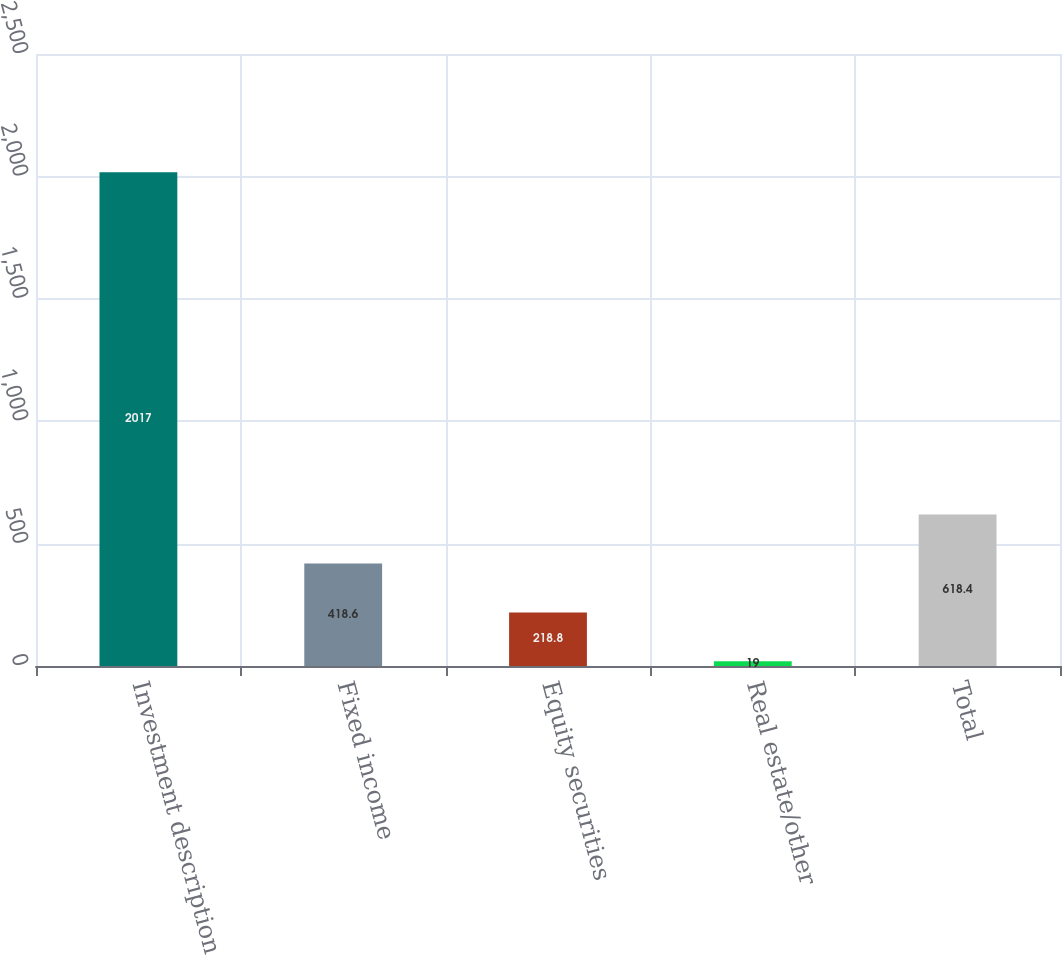Convert chart to OTSL. <chart><loc_0><loc_0><loc_500><loc_500><bar_chart><fcel>Investment description<fcel>Fixed income<fcel>Equity securities<fcel>Real estate/other<fcel>Total<nl><fcel>2017<fcel>418.6<fcel>218.8<fcel>19<fcel>618.4<nl></chart> 